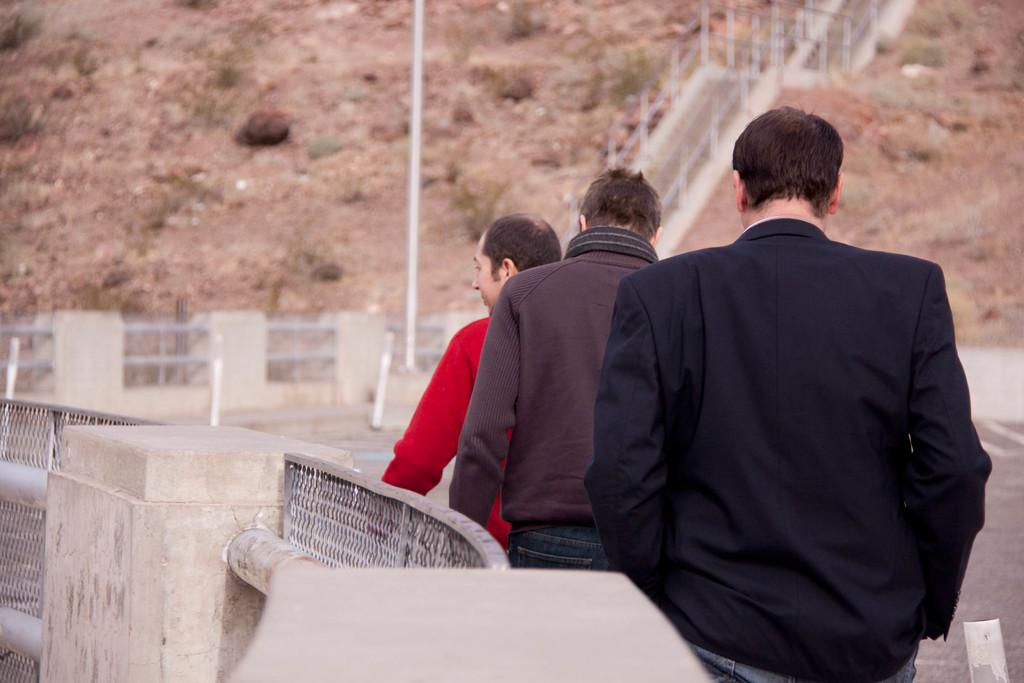What are the persons in the image wearing? The persons in the image are wearing clothes. What can be seen on the hill in the image? There are stairs on a hill in the image. What is located at the top of the image? There is a pole at the top of the image. What type of brain can be seen at the top of the pole in the image? There is no brain present in the image; only a pole is located at the top of the image. 